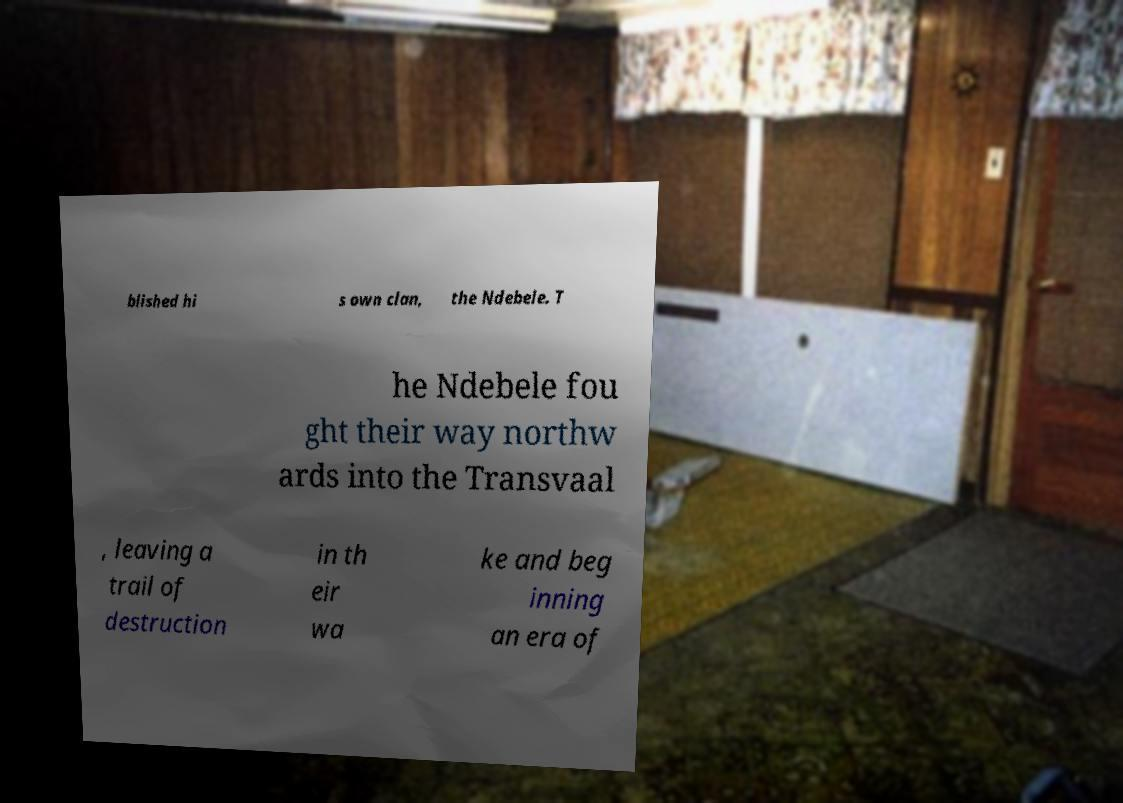Can you read and provide the text displayed in the image?This photo seems to have some interesting text. Can you extract and type it out for me? blished hi s own clan, the Ndebele. T he Ndebele fou ght their way northw ards into the Transvaal , leaving a trail of destruction in th eir wa ke and beg inning an era of 